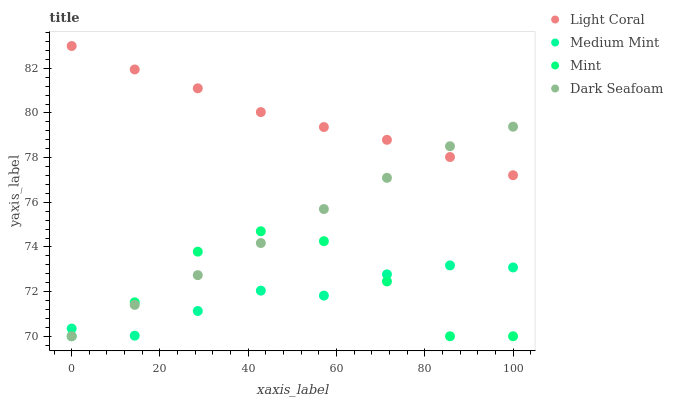Does Medium Mint have the minimum area under the curve?
Answer yes or no. Yes. Does Light Coral have the maximum area under the curve?
Answer yes or no. Yes. Does Dark Seafoam have the minimum area under the curve?
Answer yes or no. No. Does Dark Seafoam have the maximum area under the curve?
Answer yes or no. No. Is Dark Seafoam the smoothest?
Answer yes or no. Yes. Is Mint the roughest?
Answer yes or no. Yes. Is Medium Mint the smoothest?
Answer yes or no. No. Is Medium Mint the roughest?
Answer yes or no. No. Does Dark Seafoam have the lowest value?
Answer yes or no. Yes. Does Medium Mint have the lowest value?
Answer yes or no. No. Does Light Coral have the highest value?
Answer yes or no. Yes. Does Dark Seafoam have the highest value?
Answer yes or no. No. Is Mint less than Light Coral?
Answer yes or no. Yes. Is Light Coral greater than Medium Mint?
Answer yes or no. Yes. Does Medium Mint intersect Dark Seafoam?
Answer yes or no. Yes. Is Medium Mint less than Dark Seafoam?
Answer yes or no. No. Is Medium Mint greater than Dark Seafoam?
Answer yes or no. No. Does Mint intersect Light Coral?
Answer yes or no. No. 